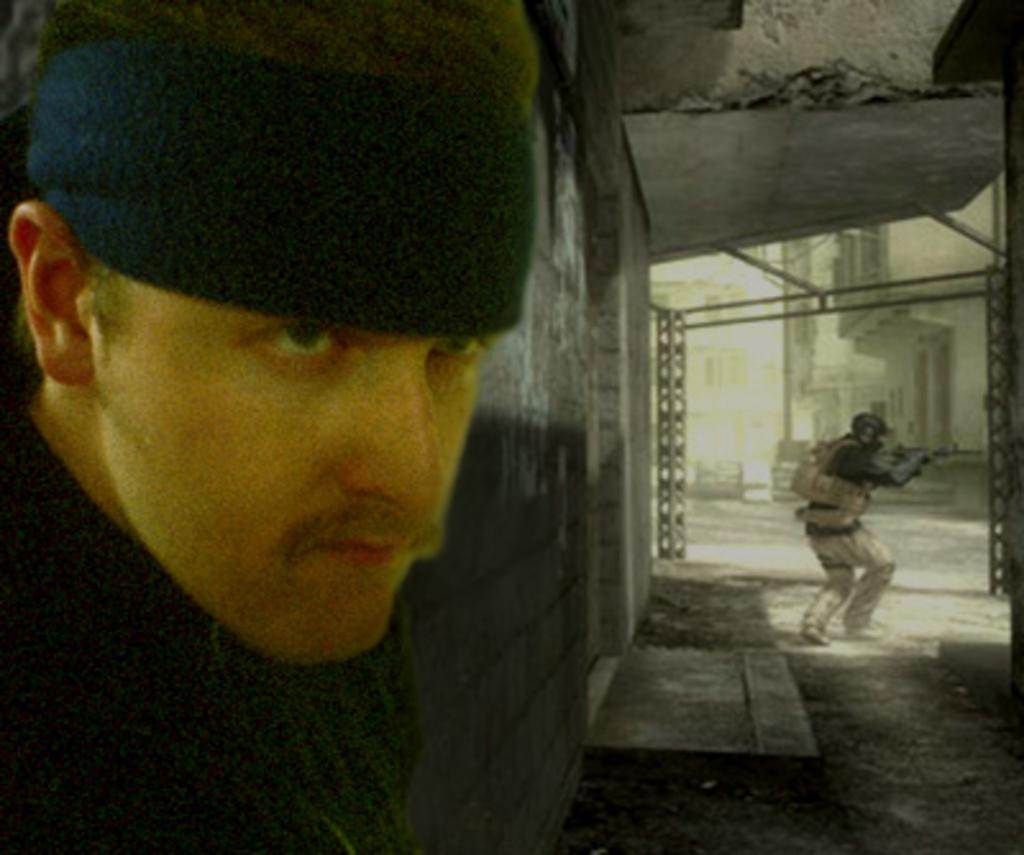How many people are present in the image? There are two persons in the image. What is happening in the background of the image? In the background, a person is holding an object. What type of structures can be seen in the background? There are buildings visible in the background. What else can be seen in the background of the image? There are poles in the background. What route is the stage taking in the image? There is no stage or route present in the image. What type of knowledge is being shared by the persons in the image? The image does not provide any information about knowledge being shared between the persons. 